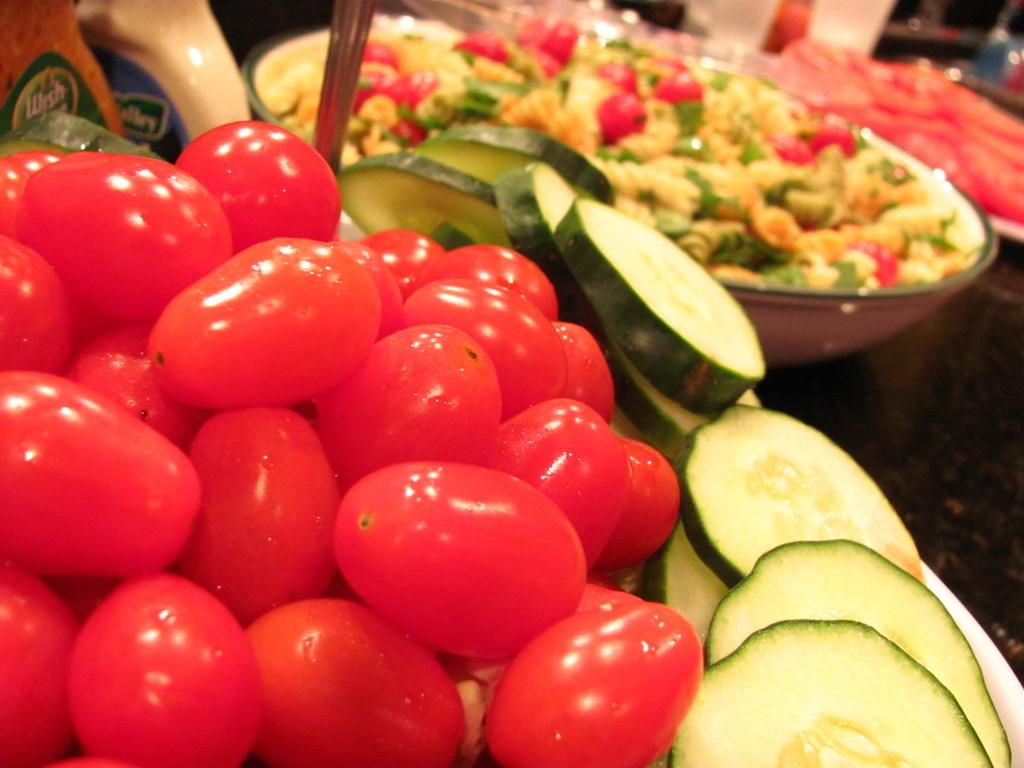What type of food items can be seen in the image? There are vegetables in the image, which are a type of food item. Can you describe any other food items in the image? The facts provided do not specify any other food items besides vegetables. What else is present in the image besides food items? There are other objects present in the image, but their specific nature is not mentioned in the facts. Is there a hydrant visible in the image? No, there is no hydrant present in the image. Is the boy playing with the snow in the image? There is no boy or snow present in the image. 